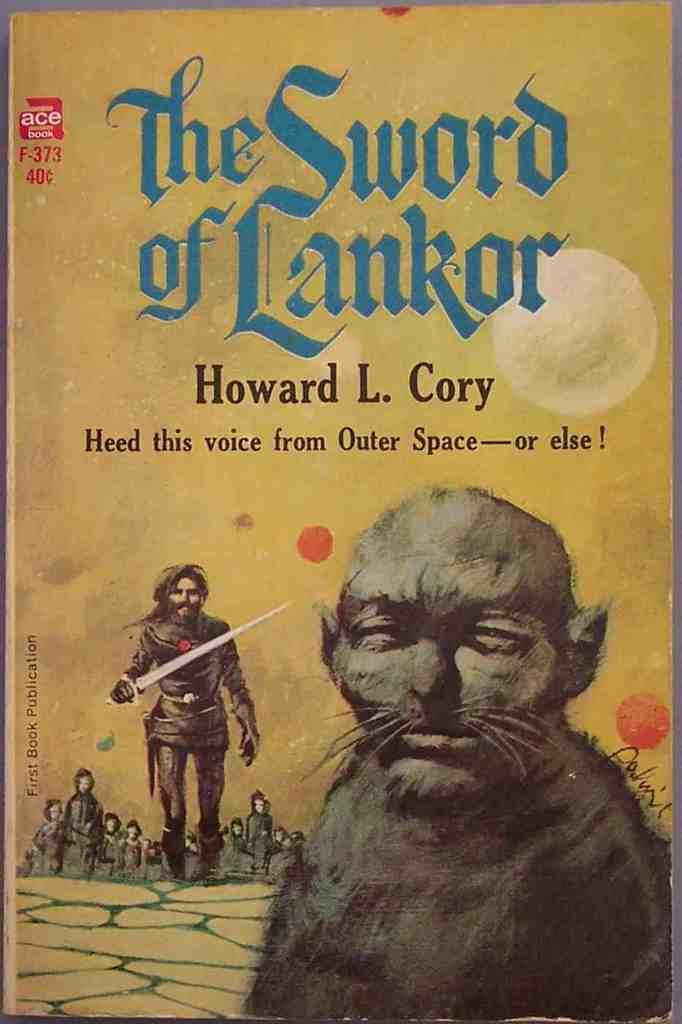Who wrote this story?
Give a very brief answer. Howard l. cory. 